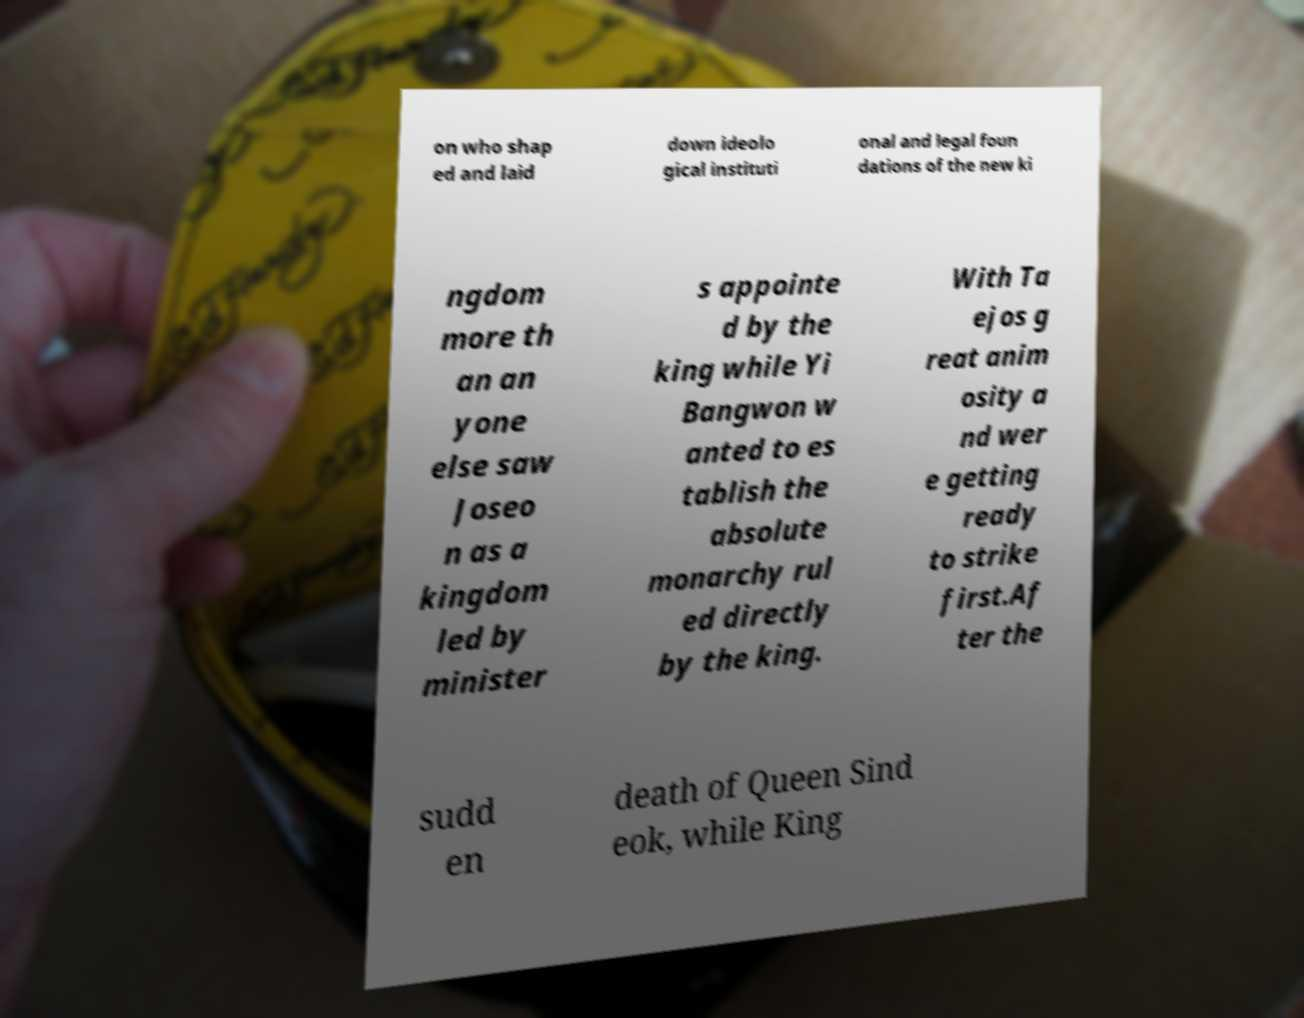Could you extract and type out the text from this image? on who shap ed and laid down ideolo gical instituti onal and legal foun dations of the new ki ngdom more th an an yone else saw Joseo n as a kingdom led by minister s appointe d by the king while Yi Bangwon w anted to es tablish the absolute monarchy rul ed directly by the king. With Ta ejos g reat anim osity a nd wer e getting ready to strike first.Af ter the sudd en death of Queen Sind eok, while King 